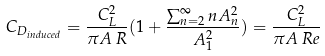<formula> <loc_0><loc_0><loc_500><loc_500>C _ { D _ { i n d u c e d } } = { \frac { C _ { L } ^ { 2 } } { \pi A \, R } } ( 1 + { \frac { \sum _ { n = 2 } ^ { \infty } n A _ { n } ^ { 2 } } { A _ { 1 } ^ { 2 } } } ) = { \frac { C _ { L } ^ { 2 } } { \pi A \, R e } }</formula> 